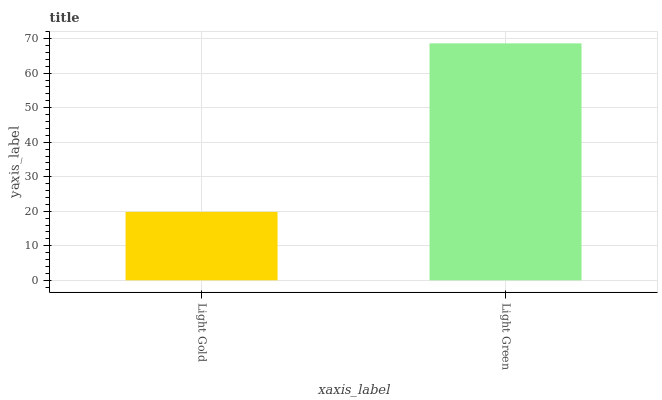Is Light Gold the minimum?
Answer yes or no. Yes. Is Light Green the maximum?
Answer yes or no. Yes. Is Light Green the minimum?
Answer yes or no. No. Is Light Green greater than Light Gold?
Answer yes or no. Yes. Is Light Gold less than Light Green?
Answer yes or no. Yes. Is Light Gold greater than Light Green?
Answer yes or no. No. Is Light Green less than Light Gold?
Answer yes or no. No. Is Light Green the high median?
Answer yes or no. Yes. Is Light Gold the low median?
Answer yes or no. Yes. Is Light Gold the high median?
Answer yes or no. No. Is Light Green the low median?
Answer yes or no. No. 